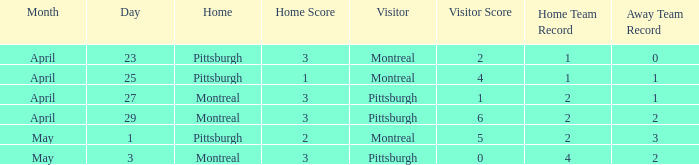What was the score on April 25? 1-4. 